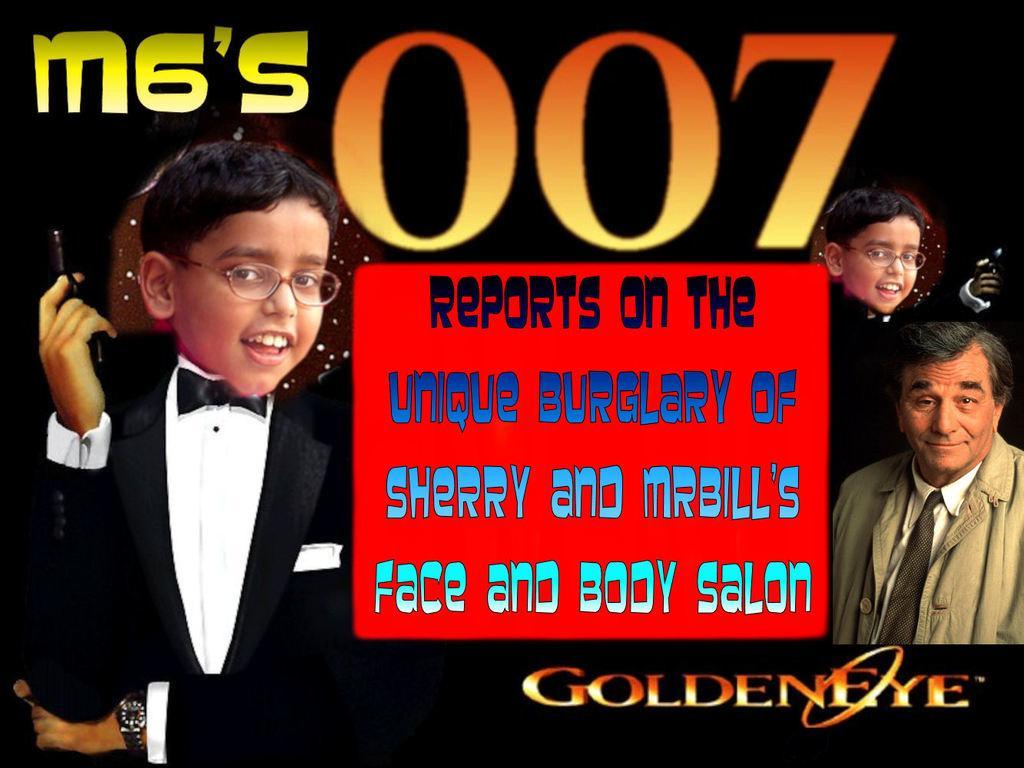How would you summarize this image in a sentence or two? In this image I can see few people with different color dresses. I can see the people holding the weapons. In-between these people I can see red color board and something is written on it. And there is a black background. 